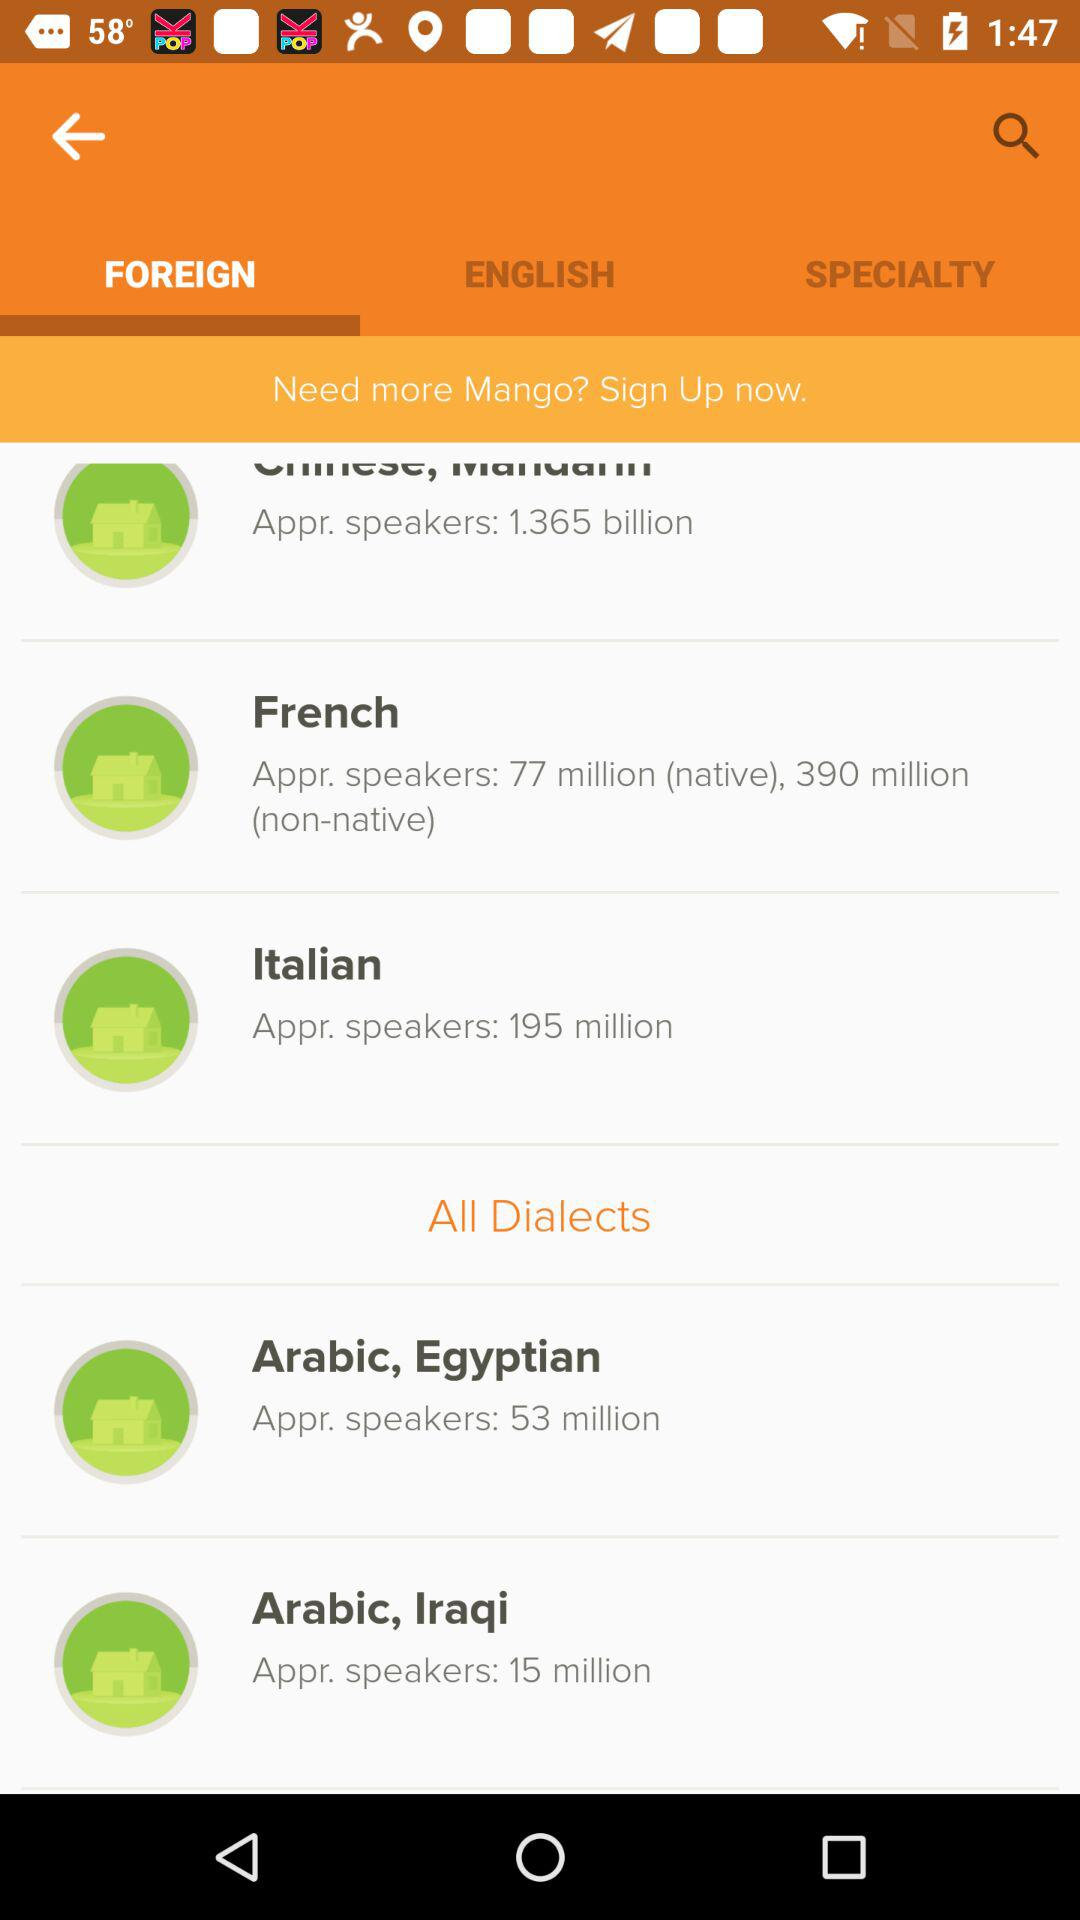Which tab is selected right now? The selected tab is "FOREIGN". 